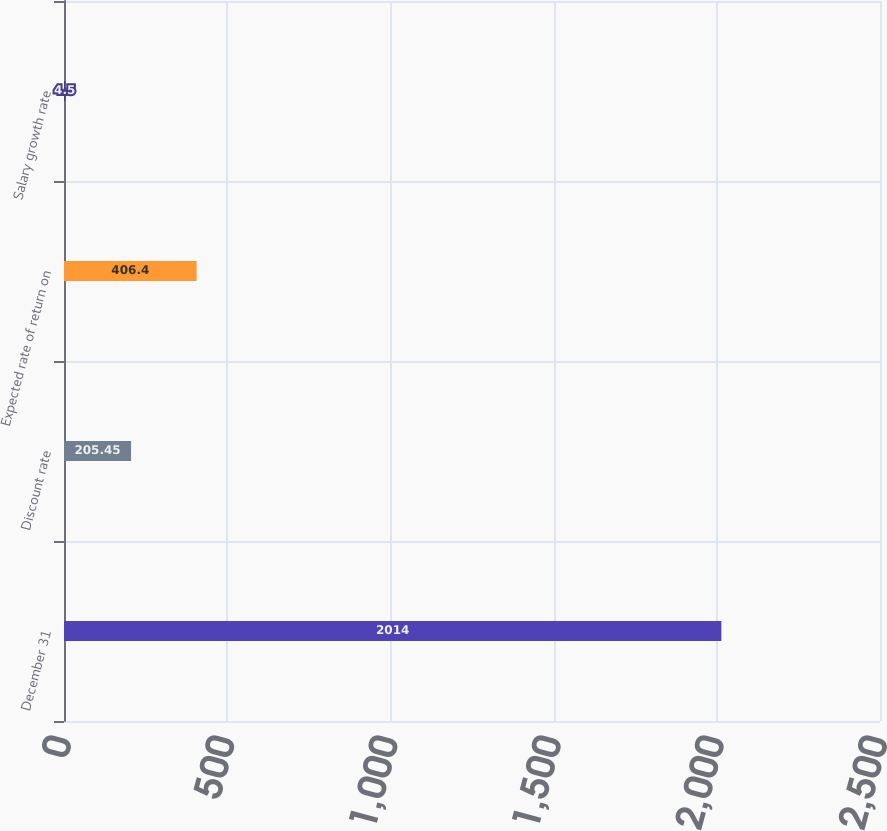<chart> <loc_0><loc_0><loc_500><loc_500><bar_chart><fcel>December 31<fcel>Discount rate<fcel>Expected rate of return on<fcel>Salary growth rate<nl><fcel>2014<fcel>205.45<fcel>406.4<fcel>4.5<nl></chart> 